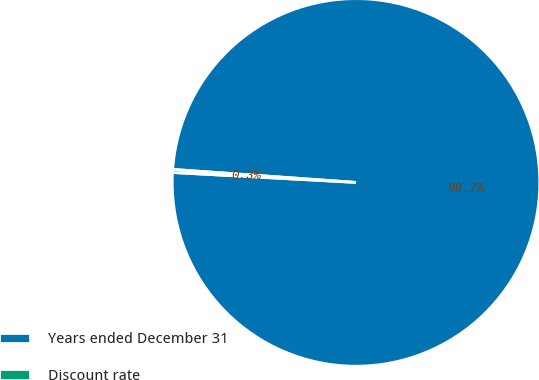Convert chart. <chart><loc_0><loc_0><loc_500><loc_500><pie_chart><fcel>Years ended December 31<fcel>Discount rate<nl><fcel>99.73%<fcel>0.27%<nl></chart> 